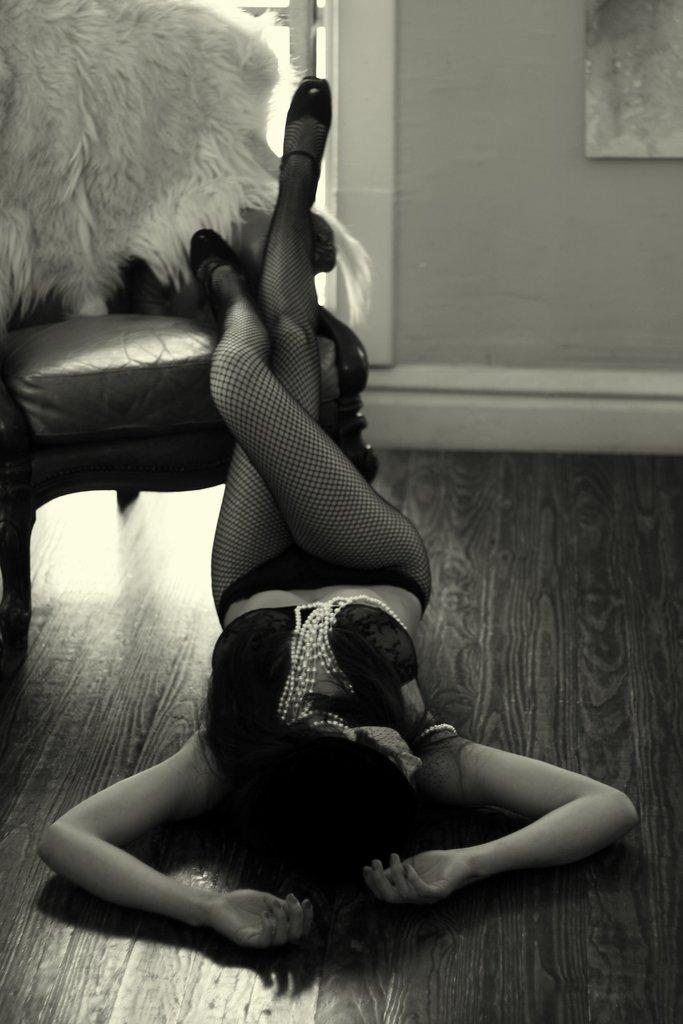Describe this image in one or two sentences. Here in this picture we can see a woman laying on the floor and in front of her we can see a chair present and we can see is placing her legs on the chair and she is wearing a costume on her over there. 